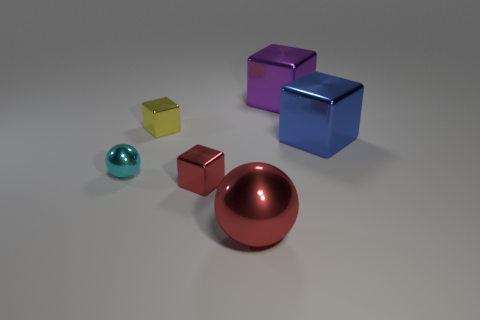How many objects in total are present in this image? There are five objects in total shown in the image, each with a distinct shape and color.  Can you describe the shapes and colors of the objects? Certainly! There's a large purple cube with a matte finish, a smaller deep red cube, a small golden-yellow cube, a teal-colored sphere, and a large shiny red sphere that almost appears metallic in its finish. 